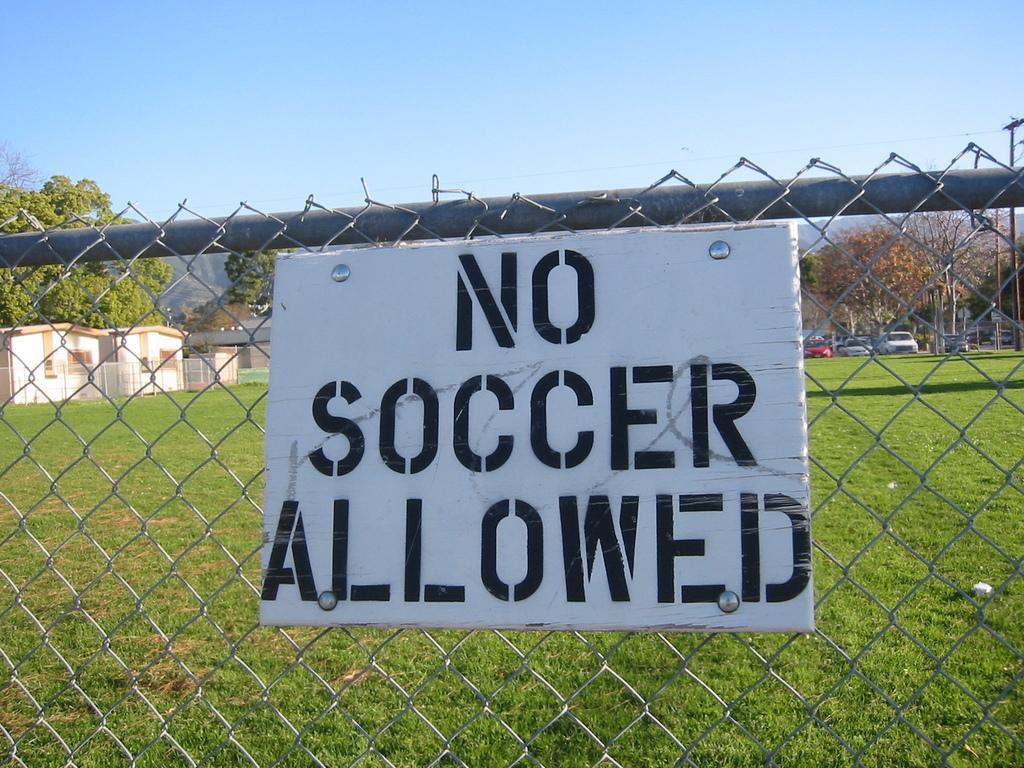How would you summarize this image in a sentence or two? In this image we can see there is a board attached to the fence. At the back there is a grass, houses, vehicles, trees and the sky. 